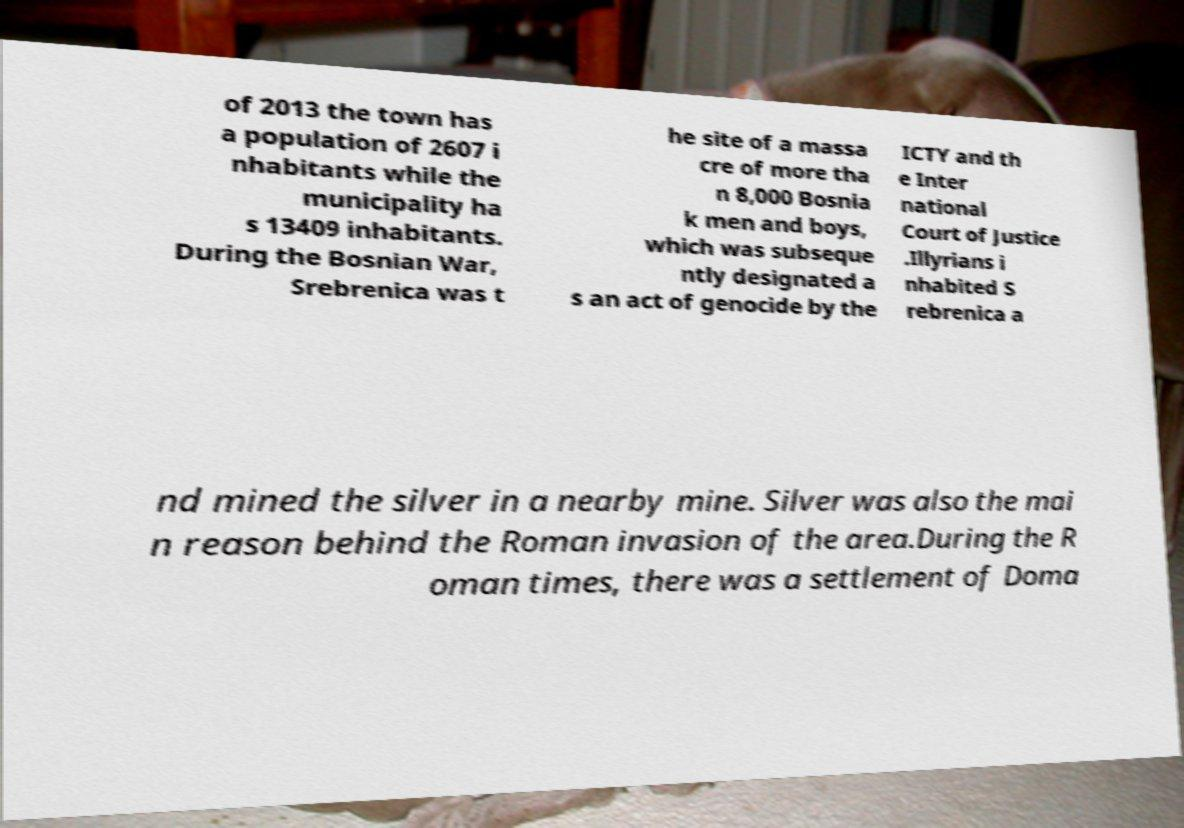There's text embedded in this image that I need extracted. Can you transcribe it verbatim? of 2013 the town has a population of 2607 i nhabitants while the municipality ha s 13409 inhabitants. During the Bosnian War, Srebrenica was t he site of a massa cre of more tha n 8,000 Bosnia k men and boys, which was subseque ntly designated a s an act of genocide by the ICTY and th e Inter national Court of Justice .Illyrians i nhabited S rebrenica a nd mined the silver in a nearby mine. Silver was also the mai n reason behind the Roman invasion of the area.During the R oman times, there was a settlement of Doma 